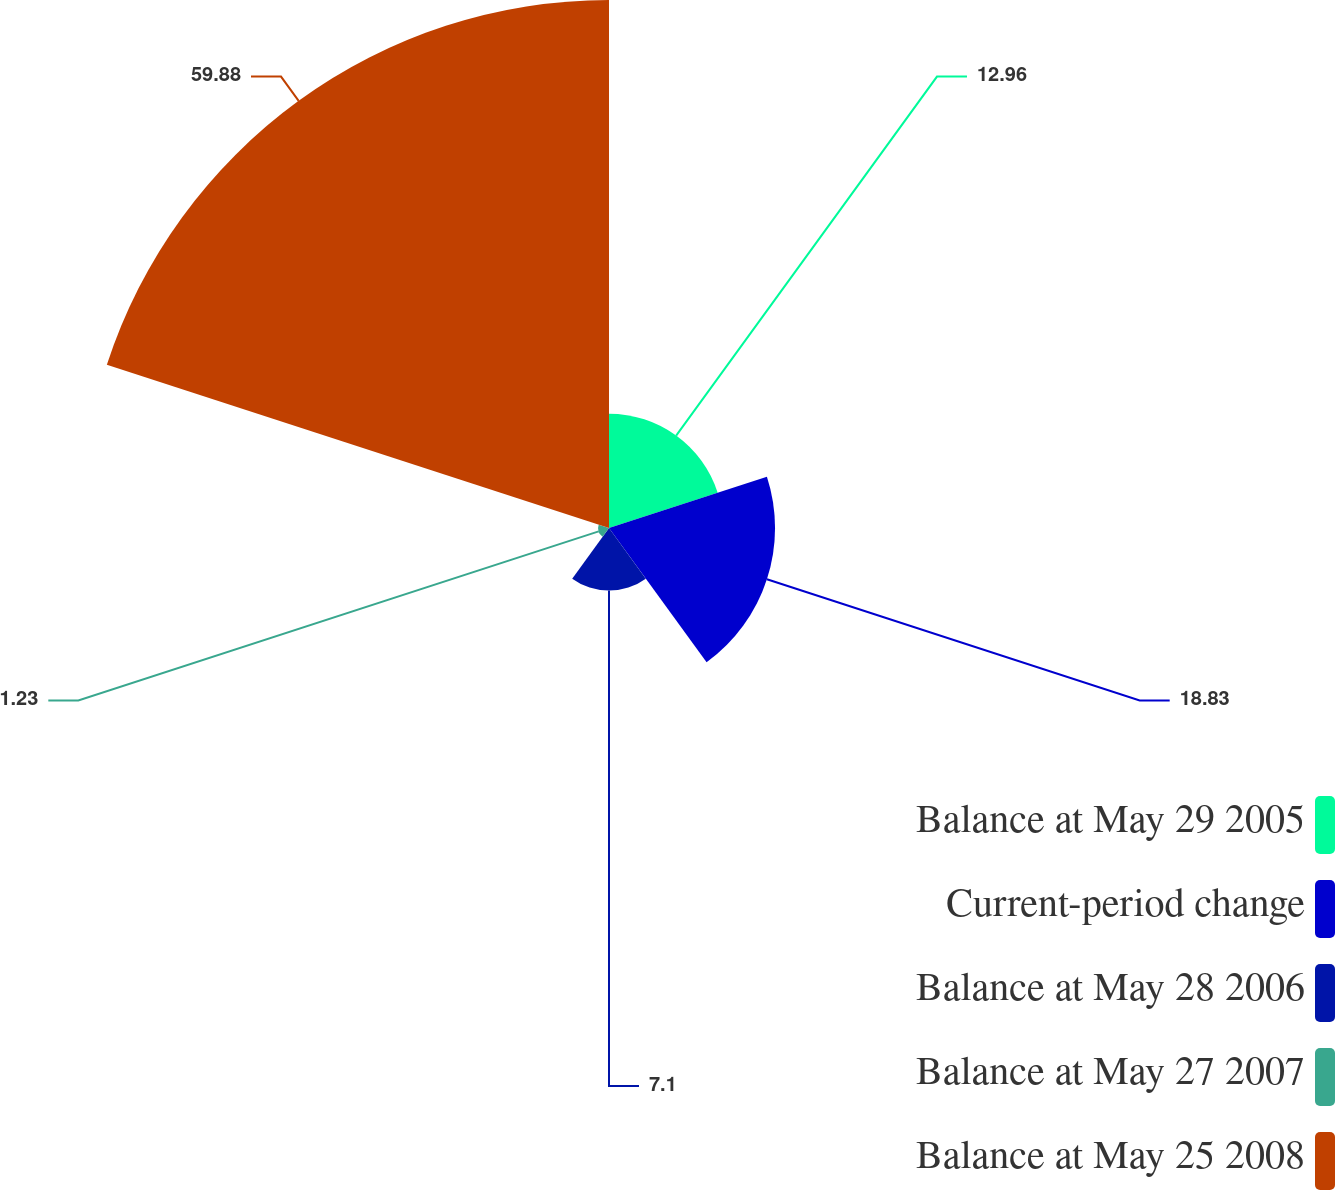<chart> <loc_0><loc_0><loc_500><loc_500><pie_chart><fcel>Balance at May 29 2005<fcel>Current-period change<fcel>Balance at May 28 2006<fcel>Balance at May 27 2007<fcel>Balance at May 25 2008<nl><fcel>12.96%<fcel>18.83%<fcel>7.1%<fcel>1.23%<fcel>59.88%<nl></chart> 